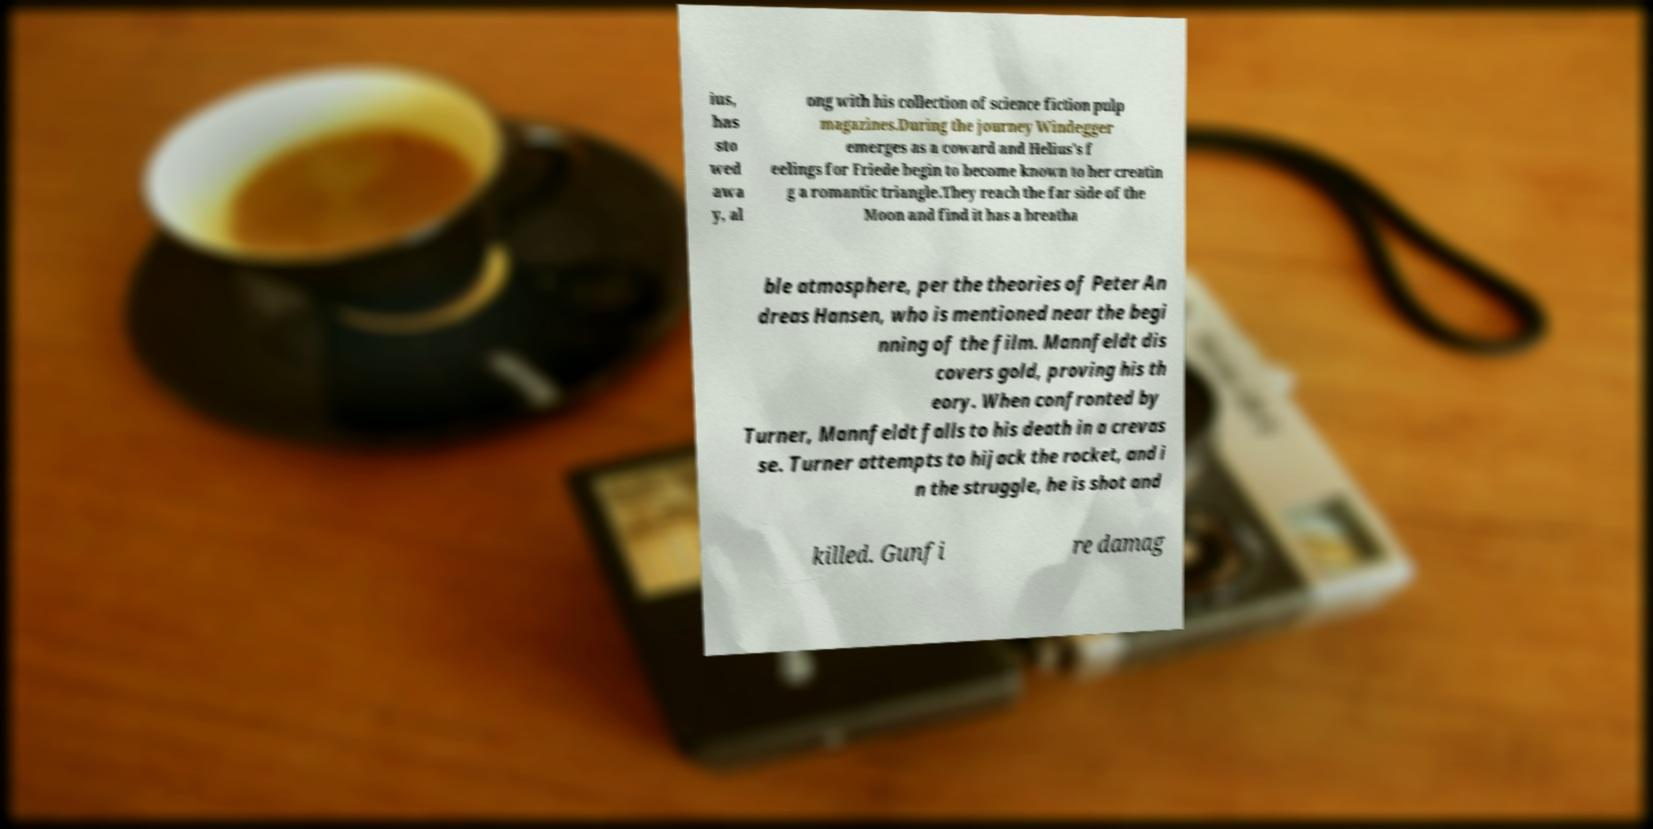Can you accurately transcribe the text from the provided image for me? ius, has sto wed awa y, al ong with his collection of science fiction pulp magazines.During the journey Windegger emerges as a coward and Helius's f eelings for Friede begin to become known to her creatin g a romantic triangle.They reach the far side of the Moon and find it has a breatha ble atmosphere, per the theories of Peter An dreas Hansen, who is mentioned near the begi nning of the film. Mannfeldt dis covers gold, proving his th eory. When confronted by Turner, Mannfeldt falls to his death in a crevas se. Turner attempts to hijack the rocket, and i n the struggle, he is shot and killed. Gunfi re damag 